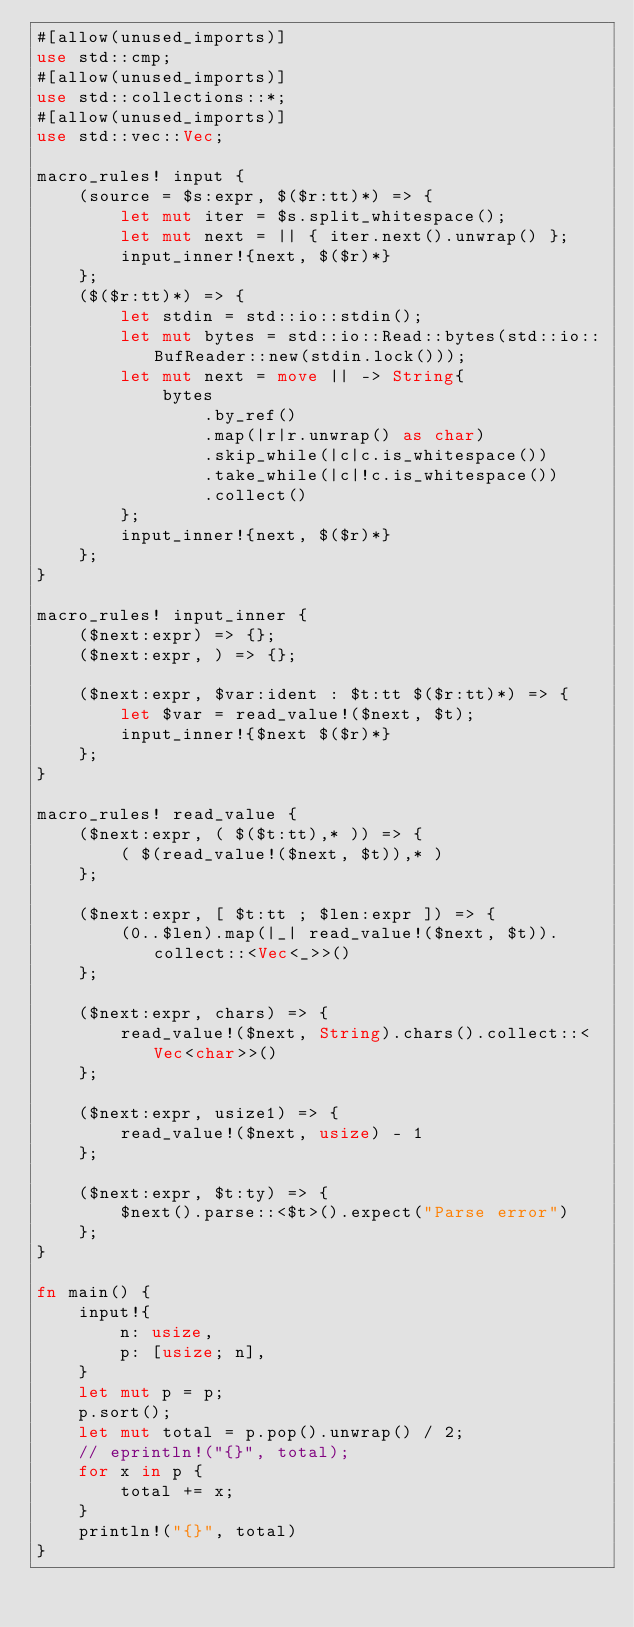<code> <loc_0><loc_0><loc_500><loc_500><_Rust_>#[allow(unused_imports)]
use std::cmp;
#[allow(unused_imports)]
use std::collections::*;
#[allow(unused_imports)]
use std::vec::Vec;

macro_rules! input {
    (source = $s:expr, $($r:tt)*) => {
        let mut iter = $s.split_whitespace();
        let mut next = || { iter.next().unwrap() };
        input_inner!{next, $($r)*}
    };
    ($($r:tt)*) => {
        let stdin = std::io::stdin();
        let mut bytes = std::io::Read::bytes(std::io::BufReader::new(stdin.lock()));
        let mut next = move || -> String{
            bytes
                .by_ref()
                .map(|r|r.unwrap() as char)
                .skip_while(|c|c.is_whitespace())
                .take_while(|c|!c.is_whitespace())
                .collect()
        };
        input_inner!{next, $($r)*}
    };
}

macro_rules! input_inner {
    ($next:expr) => {};
    ($next:expr, ) => {};

    ($next:expr, $var:ident : $t:tt $($r:tt)*) => {
        let $var = read_value!($next, $t);
        input_inner!{$next $($r)*}
    };
}

macro_rules! read_value {
    ($next:expr, ( $($t:tt),* )) => {
        ( $(read_value!($next, $t)),* )
    };

    ($next:expr, [ $t:tt ; $len:expr ]) => {
        (0..$len).map(|_| read_value!($next, $t)).collect::<Vec<_>>()
    };

    ($next:expr, chars) => {
        read_value!($next, String).chars().collect::<Vec<char>>()
    };

    ($next:expr, usize1) => {
        read_value!($next, usize) - 1
    };

    ($next:expr, $t:ty) => {
        $next().parse::<$t>().expect("Parse error")
    };
}

fn main() {
    input!{
        n: usize,
        p: [usize; n],
    }
    let mut p = p;
    p.sort();
    let mut total = p.pop().unwrap() / 2;
    // eprintln!("{}", total);
    for x in p {
        total += x;
    }
    println!("{}", total)
}
</code> 